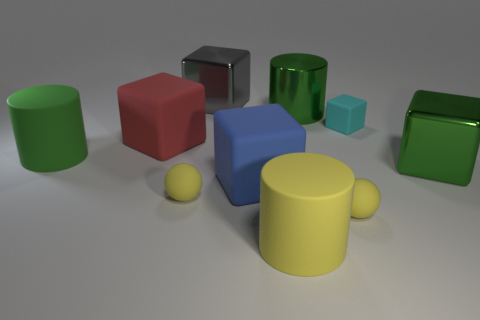Subtract all big shiny cylinders. How many cylinders are left? 2 Subtract all yellow cylinders. How many cylinders are left? 2 Subtract 2 spheres. How many spheres are left? 0 Subtract all balls. How many objects are left? 8 Subtract all tiny blue cylinders. Subtract all large green metal cylinders. How many objects are left? 9 Add 4 shiny blocks. How many shiny blocks are left? 6 Add 6 tiny yellow things. How many tiny yellow things exist? 8 Subtract 0 purple cylinders. How many objects are left? 10 Subtract all gray blocks. Subtract all cyan balls. How many blocks are left? 4 Subtract all gray spheres. How many yellow cylinders are left? 1 